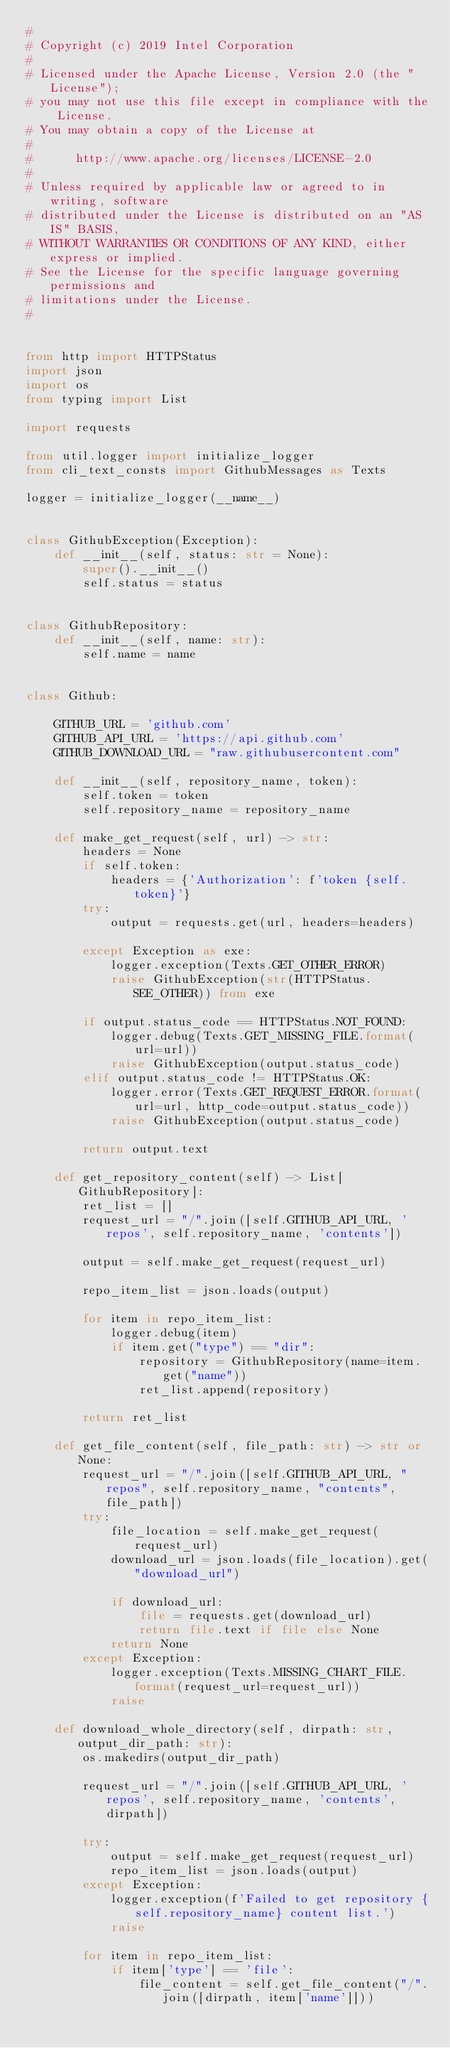Convert code to text. <code><loc_0><loc_0><loc_500><loc_500><_Python_>#
# Copyright (c) 2019 Intel Corporation
#
# Licensed under the Apache License, Version 2.0 (the "License");
# you may not use this file except in compliance with the License.
# You may obtain a copy of the License at
#
#      http://www.apache.org/licenses/LICENSE-2.0
#
# Unless required by applicable law or agreed to in writing, software
# distributed under the License is distributed on an "AS IS" BASIS,
# WITHOUT WARRANTIES OR CONDITIONS OF ANY KIND, either express or implied.
# See the License for the specific language governing permissions and
# limitations under the License.
#


from http import HTTPStatus
import json
import os
from typing import List

import requests

from util.logger import initialize_logger
from cli_text_consts import GithubMessages as Texts

logger = initialize_logger(__name__)


class GithubException(Exception):
    def __init__(self, status: str = None):
        super().__init__()
        self.status = status


class GithubRepository:
    def __init__(self, name: str):
        self.name = name


class Github:

    GITHUB_URL = 'github.com'
    GITHUB_API_URL = 'https://api.github.com'
    GITHUB_DOWNLOAD_URL = "raw.githubusercontent.com"

    def __init__(self, repository_name, token):
        self.token = token
        self.repository_name = repository_name

    def make_get_request(self, url) -> str:
        headers = None
        if self.token:
            headers = {'Authorization': f'token {self.token}'}
        try:
            output = requests.get(url, headers=headers)

        except Exception as exe:
            logger.exception(Texts.GET_OTHER_ERROR)
            raise GithubException(str(HTTPStatus.SEE_OTHER)) from exe

        if output.status_code == HTTPStatus.NOT_FOUND:
            logger.debug(Texts.GET_MISSING_FILE.format(url=url))
            raise GithubException(output.status_code)
        elif output.status_code != HTTPStatus.OK:
            logger.error(Texts.GET_REQUEST_ERROR.format(url=url, http_code=output.status_code))
            raise GithubException(output.status_code)

        return output.text

    def get_repository_content(self) -> List[GithubRepository]:
        ret_list = []
        request_url = "/".join([self.GITHUB_API_URL, 'repos', self.repository_name, 'contents'])

        output = self.make_get_request(request_url)

        repo_item_list = json.loads(output)

        for item in repo_item_list:
            logger.debug(item)
            if item.get("type") == "dir":
                repository = GithubRepository(name=item.get("name"))
                ret_list.append(repository)

        return ret_list

    def get_file_content(self, file_path: str) -> str or None:
        request_url = "/".join([self.GITHUB_API_URL, "repos", self.repository_name, "contents", file_path])
        try:
            file_location = self.make_get_request(request_url)
            download_url = json.loads(file_location).get("download_url")

            if download_url:
                file = requests.get(download_url)
                return file.text if file else None
            return None
        except Exception:
            logger.exception(Texts.MISSING_CHART_FILE.format(request_url=request_url))
            raise

    def download_whole_directory(self, dirpath: str, output_dir_path: str):
        os.makedirs(output_dir_path)

        request_url = "/".join([self.GITHUB_API_URL, 'repos', self.repository_name, 'contents', dirpath])

        try:
            output = self.make_get_request(request_url)
            repo_item_list = json.loads(output)
        except Exception:
            logger.exception(f'Failed to get repository {self.repository_name} content list.')
            raise

        for item in repo_item_list:
            if item['type'] == 'file':
                file_content = self.get_file_content("/".join([dirpath, item['name']]))</code> 